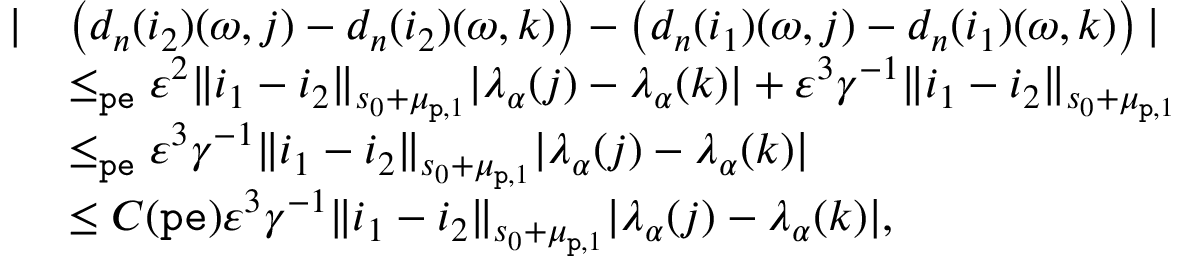<formula> <loc_0><loc_0><loc_500><loc_500>\begin{array} { r l } { | } & { \left ( d _ { n } ( i _ { 2 } ) ( \omega , j ) - d _ { n } ( i _ { 2 } ) ( \omega , k ) \right ) - \left ( d _ { n } ( i _ { 1 } ) ( \omega , j ) - d _ { n } ( i _ { 1 } ) ( \omega , k ) \right ) | } \\ & { \leq _ { p e } \varepsilon ^ { 2 } \| i _ { 1 } - i _ { 2 } \| _ { s _ { 0 } + \mu _ { p , 1 } } | \lambda _ { \alpha } ( j ) - \lambda _ { \alpha } ( k ) | + \varepsilon ^ { 3 } \gamma ^ { - 1 } \| i _ { 1 } - i _ { 2 } \| _ { s _ { 0 } + \mu _ { p , 1 } } } \\ & { \leq _ { p e } \varepsilon ^ { 3 } \gamma ^ { - 1 } \| i _ { 1 } - i _ { 2 } \| _ { s _ { 0 } + \mu _ { p , 1 } } | \lambda _ { \alpha } ( j ) - \lambda _ { \alpha } ( k ) | } \\ & { \leq C ( { p e } ) \varepsilon ^ { 3 } \gamma ^ { - 1 } \| i _ { 1 } - i _ { 2 } \| _ { s _ { 0 } + \mu _ { p , 1 } } | \lambda _ { \alpha } ( j ) - \lambda _ { \alpha } ( k ) | , } \end{array}</formula> 